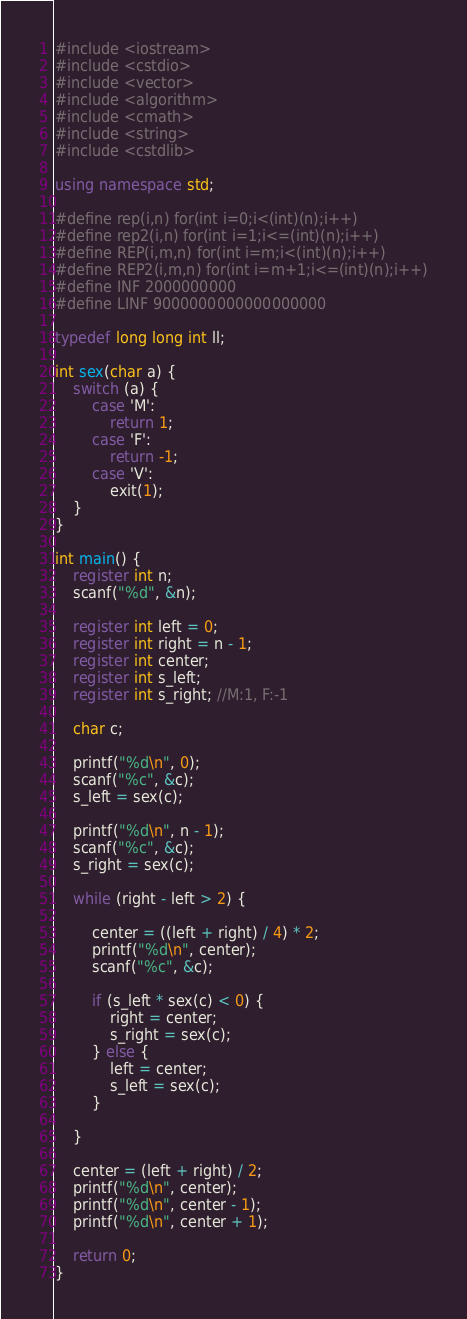<code> <loc_0><loc_0><loc_500><loc_500><_C++_>#include <iostream>
#include <cstdio>
#include <vector>
#include <algorithm>
#include <cmath>
#include <string>
#include <cstdlib>

using namespace std;

#define rep(i,n) for(int i=0;i<(int)(n);i++)
#define rep2(i,n) for(int i=1;i<=(int)(n);i++)
#define REP(i,m,n) for(int i=m;i<(int)(n);i++)
#define REP2(i,m,n) for(int i=m+1;i<=(int)(n);i++)
#define INF 2000000000
#define LINF 9000000000000000000

typedef long long int ll;

int sex(char a) {
    switch (a) {
        case 'M':
            return 1;
        case 'F':
            return -1;
        case 'V':
            exit(1);
    }
}

int main() {
    register int n;
    scanf("%d", &n);

    register int left = 0;
    register int right = n - 1;
    register int center;
    register int s_left;
    register int s_right; //M:1, F:-1

    char c;

    printf("%d\n", 0);
    scanf("%c", &c);
    s_left = sex(c);

    printf("%d\n", n - 1);
    scanf("%c", &c);
    s_right = sex(c);

    while (right - left > 2) {

        center = ((left + right) / 4) * 2;
        printf("%d\n", center);
        scanf("%c", &c);

        if (s_left * sex(c) < 0) {
            right = center;
            s_right = sex(c);
        } else {
            left = center;
            s_left = sex(c);
        }

    }

    center = (left + right) / 2;
    printf("%d\n", center);
    printf("%d\n", center - 1);
    printf("%d\n", center + 1);

    return 0;
}</code> 